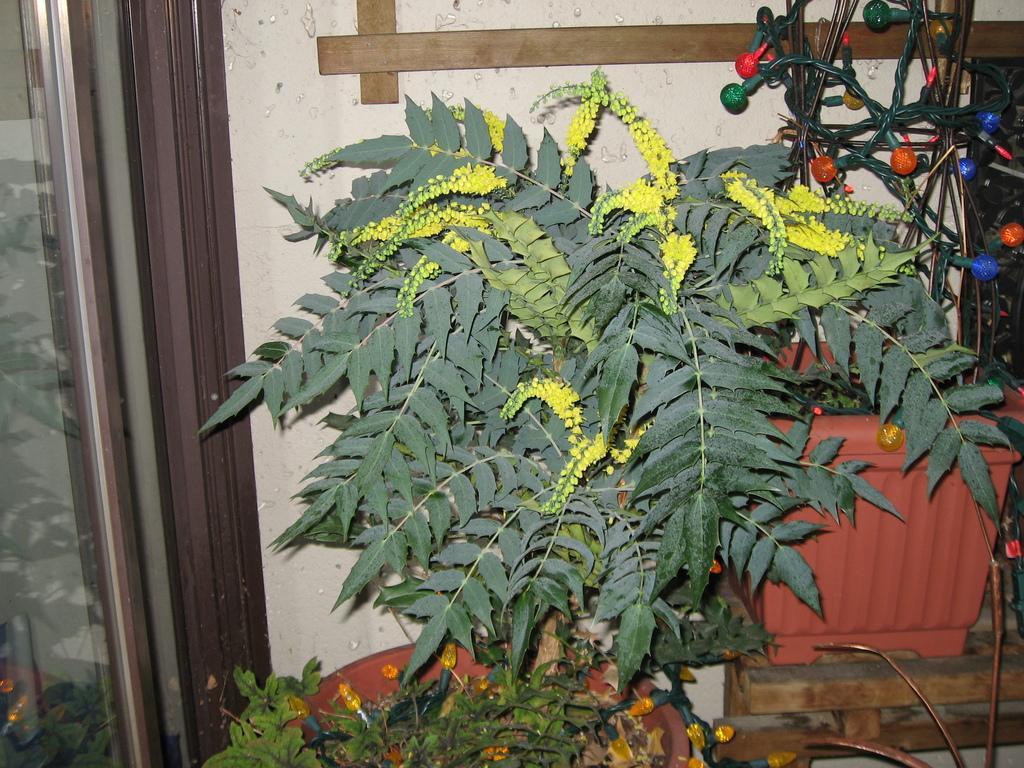How would you summarize this image in a sentence or two? In the middle of the image we can see some plants. Behind the plants there is wall. 